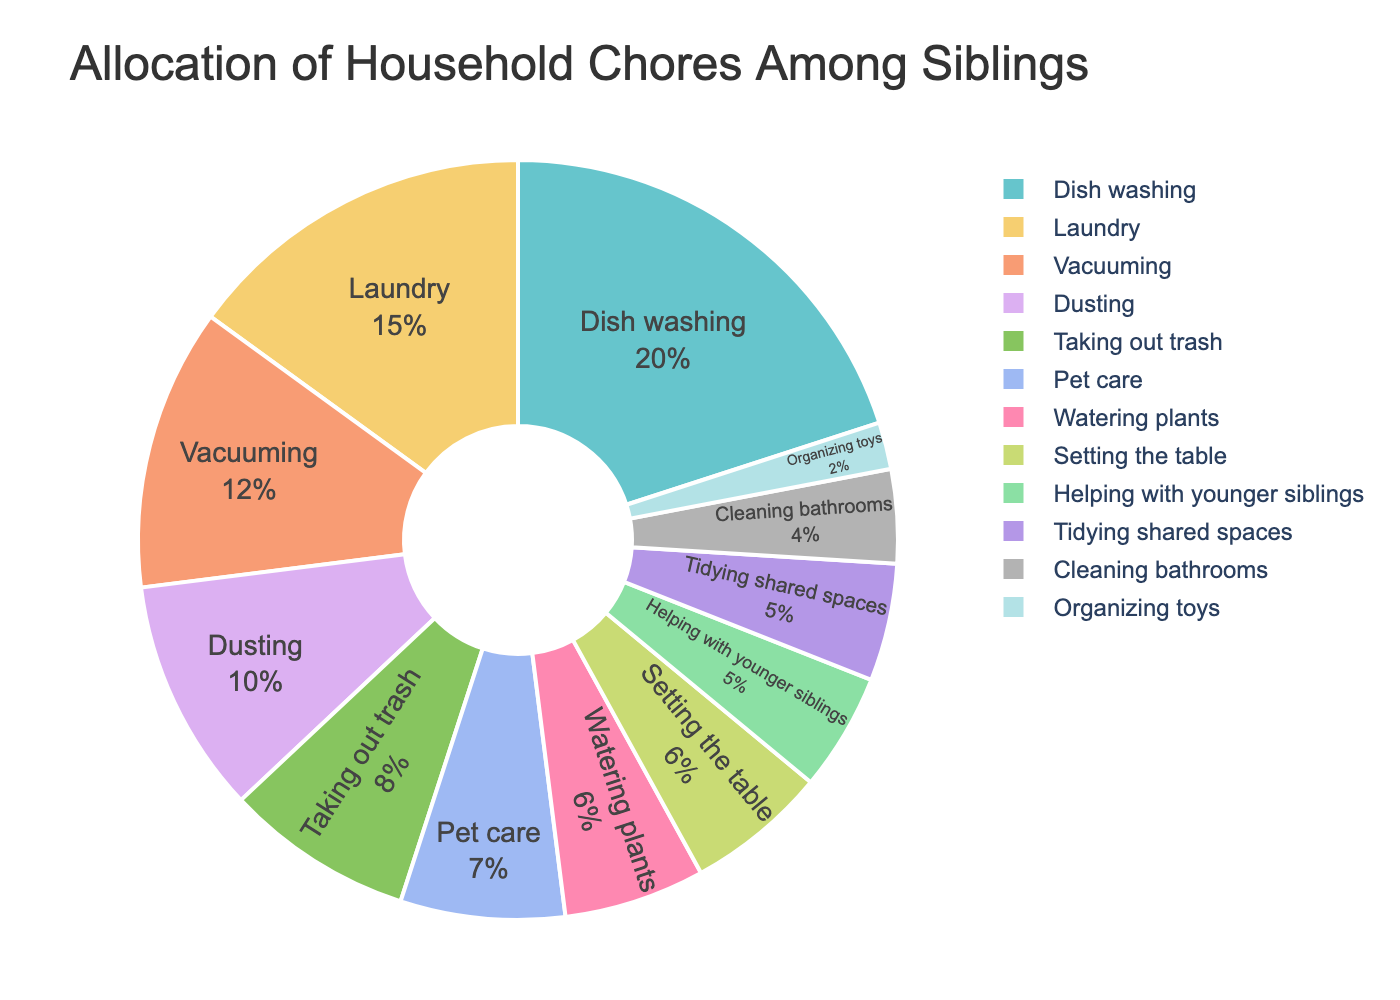Which chore occupies the largest percentage in the pie chart? By looking at the pie chart, the section labeled "Dish washing" is the largest.
Answer: Dish washing Which chores together make up a third of the total percentage? The pie chart shows Dish washing (20%) + Laundry (15%), which together sum up to 35%.
Answer: Dish washing and Laundry How do the combined percentages of Pet care and Watering plants compare to the percentage of Dish washing? Pet care (7%) + Watering plants (6%) equals 13%, which is less than the 20% of Dish washing.
Answer: Less What is the combined percentage of Taking out trash, Pet care, and Watering plants? Adding their percentages: Taking out trash (8%) + Pet care (7%) + Watering plants (6%) = 21%.
Answer: 21% Which chore has the smallest share in the pie chart? The smallest segment in the pie chart is for "Organizing toys" with 2%.
Answer: Organizing toys Is the percentage of Tidying shared spaces greater than or equal to Cleaning bathrooms? Tidying shared spaces is at 5%, whereas Cleaning bathrooms is at 4%, so Tidying shared spaces is greater.
Answer: Greater Whatever is the difference in percentage between Laundry and Vacuuming? Laundry is 15% and Vacuuming is 12%, so the difference is 15% - 12% = 3%.
Answer: 3% Is the percentage share of Dusting higher than the combined percentage of Helping with younger siblings and Cleaning bathrooms? Dusting is 10%, while Helping with younger siblings (5%) + Cleaning bathrooms (4%) is 9%. Thus, Dusting is higher.
Answer: Higher Compare the visual size of the section for Setting the table with that of Watering plants. Both Setting the table and Watering plants have the same percentage of 6%, so visually they should be equal in size in the pie chart.
Answer: Equal 